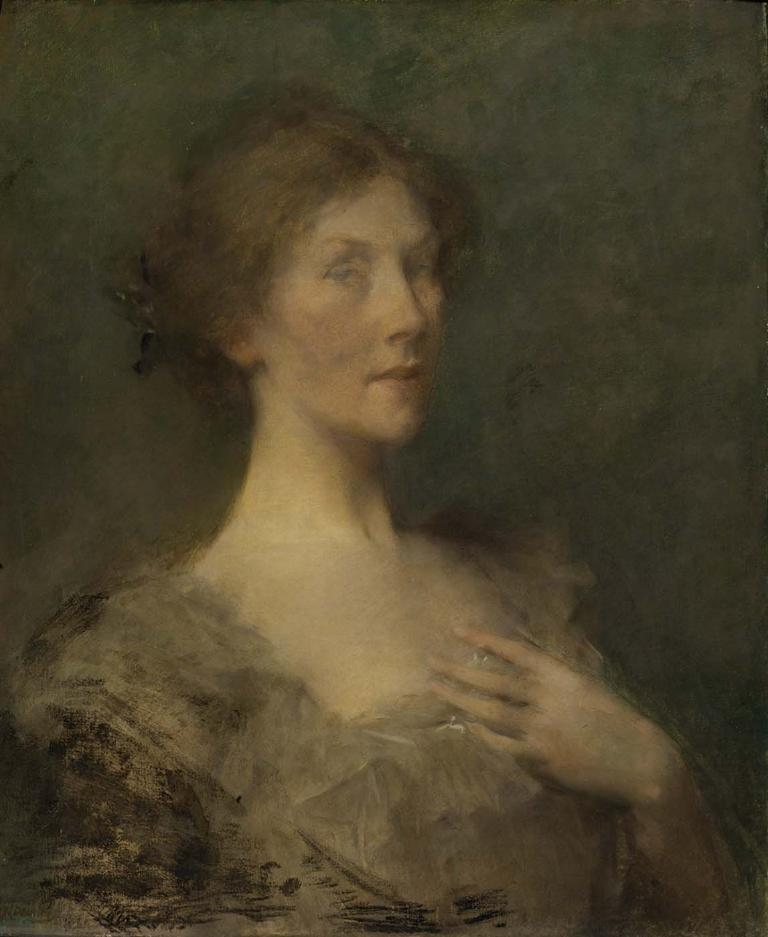What is the main subject of the image? There is a painting in the image. What is depicted in the painting? The painting depicts a woman. What color are the sides of the painting? The sides of the painting are black. What type of juice is being served in the painting? There is no juice present in the image, as it features a painting of a woman with black sides. What color is the underwear worn by the woman in the painting? The painting does not show the woman's underwear, so it cannot be determined from the image. 